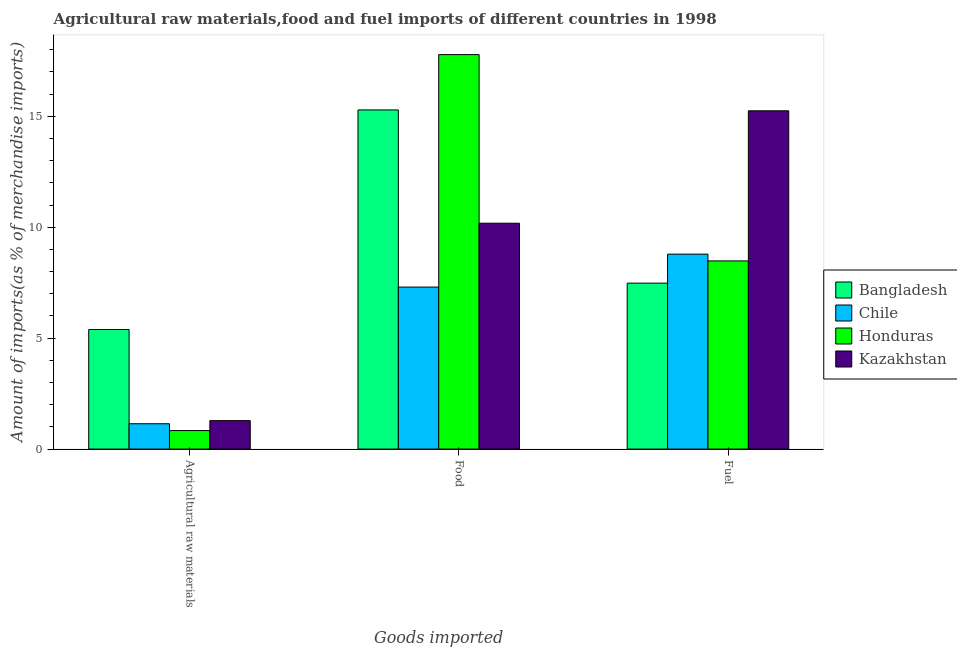How many groups of bars are there?
Your answer should be compact. 3. Are the number of bars per tick equal to the number of legend labels?
Ensure brevity in your answer.  Yes. What is the label of the 3rd group of bars from the left?
Your answer should be very brief. Fuel. What is the percentage of raw materials imports in Chile?
Your answer should be compact. 1.14. Across all countries, what is the maximum percentage of food imports?
Offer a very short reply. 17.78. Across all countries, what is the minimum percentage of food imports?
Make the answer very short. 7.3. In which country was the percentage of food imports minimum?
Offer a terse response. Chile. What is the total percentage of food imports in the graph?
Your answer should be compact. 50.55. What is the difference between the percentage of fuel imports in Honduras and that in Chile?
Give a very brief answer. -0.31. What is the difference between the percentage of fuel imports in Honduras and the percentage of raw materials imports in Kazakhstan?
Your answer should be compact. 7.2. What is the average percentage of food imports per country?
Your answer should be very brief. 12.64. What is the difference between the percentage of raw materials imports and percentage of fuel imports in Honduras?
Your response must be concise. -7.65. What is the ratio of the percentage of fuel imports in Bangladesh to that in Chile?
Your answer should be compact. 0.85. Is the percentage of fuel imports in Bangladesh less than that in Chile?
Offer a terse response. Yes. Is the difference between the percentage of fuel imports in Honduras and Chile greater than the difference between the percentage of food imports in Honduras and Chile?
Your response must be concise. No. What is the difference between the highest and the second highest percentage of food imports?
Provide a succinct answer. 2.49. What is the difference between the highest and the lowest percentage of fuel imports?
Provide a succinct answer. 7.77. Is the sum of the percentage of raw materials imports in Kazakhstan and Bangladesh greater than the maximum percentage of food imports across all countries?
Keep it short and to the point. No. What does the 2nd bar from the left in Agricultural raw materials represents?
Give a very brief answer. Chile. What does the 4th bar from the right in Agricultural raw materials represents?
Provide a short and direct response. Bangladesh. Is it the case that in every country, the sum of the percentage of raw materials imports and percentage of food imports is greater than the percentage of fuel imports?
Offer a terse response. No. Are all the bars in the graph horizontal?
Keep it short and to the point. No. How many countries are there in the graph?
Your answer should be compact. 4. Are the values on the major ticks of Y-axis written in scientific E-notation?
Offer a terse response. No. Does the graph contain any zero values?
Provide a succinct answer. No. Does the graph contain grids?
Offer a terse response. No. Where does the legend appear in the graph?
Your answer should be very brief. Center right. How many legend labels are there?
Offer a very short reply. 4. What is the title of the graph?
Your response must be concise. Agricultural raw materials,food and fuel imports of different countries in 1998. Does "Norway" appear as one of the legend labels in the graph?
Keep it short and to the point. No. What is the label or title of the X-axis?
Offer a terse response. Goods imported. What is the label or title of the Y-axis?
Your response must be concise. Amount of imports(as % of merchandise imports). What is the Amount of imports(as % of merchandise imports) of Bangladesh in Agricultural raw materials?
Make the answer very short. 5.39. What is the Amount of imports(as % of merchandise imports) in Chile in Agricultural raw materials?
Offer a terse response. 1.14. What is the Amount of imports(as % of merchandise imports) of Honduras in Agricultural raw materials?
Give a very brief answer. 0.83. What is the Amount of imports(as % of merchandise imports) in Kazakhstan in Agricultural raw materials?
Make the answer very short. 1.28. What is the Amount of imports(as % of merchandise imports) in Bangladesh in Food?
Your answer should be compact. 15.29. What is the Amount of imports(as % of merchandise imports) of Chile in Food?
Provide a succinct answer. 7.3. What is the Amount of imports(as % of merchandise imports) of Honduras in Food?
Your answer should be compact. 17.78. What is the Amount of imports(as % of merchandise imports) of Kazakhstan in Food?
Make the answer very short. 10.18. What is the Amount of imports(as % of merchandise imports) of Bangladesh in Fuel?
Provide a short and direct response. 7.48. What is the Amount of imports(as % of merchandise imports) in Chile in Fuel?
Your answer should be very brief. 8.79. What is the Amount of imports(as % of merchandise imports) of Honduras in Fuel?
Your response must be concise. 8.48. What is the Amount of imports(as % of merchandise imports) of Kazakhstan in Fuel?
Keep it short and to the point. 15.25. Across all Goods imported, what is the maximum Amount of imports(as % of merchandise imports) in Bangladesh?
Offer a terse response. 15.29. Across all Goods imported, what is the maximum Amount of imports(as % of merchandise imports) in Chile?
Your answer should be very brief. 8.79. Across all Goods imported, what is the maximum Amount of imports(as % of merchandise imports) of Honduras?
Offer a terse response. 17.78. Across all Goods imported, what is the maximum Amount of imports(as % of merchandise imports) of Kazakhstan?
Provide a short and direct response. 15.25. Across all Goods imported, what is the minimum Amount of imports(as % of merchandise imports) in Bangladesh?
Your response must be concise. 5.39. Across all Goods imported, what is the minimum Amount of imports(as % of merchandise imports) in Chile?
Make the answer very short. 1.14. Across all Goods imported, what is the minimum Amount of imports(as % of merchandise imports) of Honduras?
Your answer should be very brief. 0.83. Across all Goods imported, what is the minimum Amount of imports(as % of merchandise imports) in Kazakhstan?
Ensure brevity in your answer.  1.28. What is the total Amount of imports(as % of merchandise imports) in Bangladesh in the graph?
Your answer should be compact. 28.15. What is the total Amount of imports(as % of merchandise imports) in Chile in the graph?
Your response must be concise. 17.23. What is the total Amount of imports(as % of merchandise imports) in Honduras in the graph?
Offer a terse response. 27.09. What is the total Amount of imports(as % of merchandise imports) of Kazakhstan in the graph?
Offer a very short reply. 26.71. What is the difference between the Amount of imports(as % of merchandise imports) of Bangladesh in Agricultural raw materials and that in Food?
Provide a succinct answer. -9.9. What is the difference between the Amount of imports(as % of merchandise imports) of Chile in Agricultural raw materials and that in Food?
Give a very brief answer. -6.16. What is the difference between the Amount of imports(as % of merchandise imports) in Honduras in Agricultural raw materials and that in Food?
Ensure brevity in your answer.  -16.95. What is the difference between the Amount of imports(as % of merchandise imports) of Kazakhstan in Agricultural raw materials and that in Food?
Keep it short and to the point. -8.9. What is the difference between the Amount of imports(as % of merchandise imports) in Bangladesh in Agricultural raw materials and that in Fuel?
Keep it short and to the point. -2.09. What is the difference between the Amount of imports(as % of merchandise imports) in Chile in Agricultural raw materials and that in Fuel?
Keep it short and to the point. -7.64. What is the difference between the Amount of imports(as % of merchandise imports) of Honduras in Agricultural raw materials and that in Fuel?
Ensure brevity in your answer.  -7.65. What is the difference between the Amount of imports(as % of merchandise imports) in Kazakhstan in Agricultural raw materials and that in Fuel?
Your response must be concise. -13.96. What is the difference between the Amount of imports(as % of merchandise imports) of Bangladesh in Food and that in Fuel?
Offer a very short reply. 7.81. What is the difference between the Amount of imports(as % of merchandise imports) of Chile in Food and that in Fuel?
Your answer should be very brief. -1.48. What is the difference between the Amount of imports(as % of merchandise imports) in Honduras in Food and that in Fuel?
Your answer should be very brief. 9.3. What is the difference between the Amount of imports(as % of merchandise imports) of Kazakhstan in Food and that in Fuel?
Give a very brief answer. -5.07. What is the difference between the Amount of imports(as % of merchandise imports) of Bangladesh in Agricultural raw materials and the Amount of imports(as % of merchandise imports) of Chile in Food?
Ensure brevity in your answer.  -1.91. What is the difference between the Amount of imports(as % of merchandise imports) in Bangladesh in Agricultural raw materials and the Amount of imports(as % of merchandise imports) in Honduras in Food?
Ensure brevity in your answer.  -12.39. What is the difference between the Amount of imports(as % of merchandise imports) of Bangladesh in Agricultural raw materials and the Amount of imports(as % of merchandise imports) of Kazakhstan in Food?
Give a very brief answer. -4.79. What is the difference between the Amount of imports(as % of merchandise imports) in Chile in Agricultural raw materials and the Amount of imports(as % of merchandise imports) in Honduras in Food?
Your answer should be very brief. -16.64. What is the difference between the Amount of imports(as % of merchandise imports) of Chile in Agricultural raw materials and the Amount of imports(as % of merchandise imports) of Kazakhstan in Food?
Offer a terse response. -9.04. What is the difference between the Amount of imports(as % of merchandise imports) of Honduras in Agricultural raw materials and the Amount of imports(as % of merchandise imports) of Kazakhstan in Food?
Provide a short and direct response. -9.35. What is the difference between the Amount of imports(as % of merchandise imports) of Bangladesh in Agricultural raw materials and the Amount of imports(as % of merchandise imports) of Chile in Fuel?
Make the answer very short. -3.4. What is the difference between the Amount of imports(as % of merchandise imports) in Bangladesh in Agricultural raw materials and the Amount of imports(as % of merchandise imports) in Honduras in Fuel?
Your answer should be compact. -3.09. What is the difference between the Amount of imports(as % of merchandise imports) in Bangladesh in Agricultural raw materials and the Amount of imports(as % of merchandise imports) in Kazakhstan in Fuel?
Your answer should be very brief. -9.86. What is the difference between the Amount of imports(as % of merchandise imports) of Chile in Agricultural raw materials and the Amount of imports(as % of merchandise imports) of Honduras in Fuel?
Offer a very short reply. -7.34. What is the difference between the Amount of imports(as % of merchandise imports) of Chile in Agricultural raw materials and the Amount of imports(as % of merchandise imports) of Kazakhstan in Fuel?
Your answer should be compact. -14.11. What is the difference between the Amount of imports(as % of merchandise imports) in Honduras in Agricultural raw materials and the Amount of imports(as % of merchandise imports) in Kazakhstan in Fuel?
Offer a terse response. -14.41. What is the difference between the Amount of imports(as % of merchandise imports) in Bangladesh in Food and the Amount of imports(as % of merchandise imports) in Chile in Fuel?
Keep it short and to the point. 6.5. What is the difference between the Amount of imports(as % of merchandise imports) of Bangladesh in Food and the Amount of imports(as % of merchandise imports) of Honduras in Fuel?
Provide a succinct answer. 6.81. What is the difference between the Amount of imports(as % of merchandise imports) of Bangladesh in Food and the Amount of imports(as % of merchandise imports) of Kazakhstan in Fuel?
Give a very brief answer. 0.04. What is the difference between the Amount of imports(as % of merchandise imports) in Chile in Food and the Amount of imports(as % of merchandise imports) in Honduras in Fuel?
Your response must be concise. -1.18. What is the difference between the Amount of imports(as % of merchandise imports) in Chile in Food and the Amount of imports(as % of merchandise imports) in Kazakhstan in Fuel?
Provide a succinct answer. -7.94. What is the difference between the Amount of imports(as % of merchandise imports) of Honduras in Food and the Amount of imports(as % of merchandise imports) of Kazakhstan in Fuel?
Your answer should be very brief. 2.53. What is the average Amount of imports(as % of merchandise imports) in Bangladesh per Goods imported?
Make the answer very short. 9.38. What is the average Amount of imports(as % of merchandise imports) of Chile per Goods imported?
Your answer should be very brief. 5.74. What is the average Amount of imports(as % of merchandise imports) in Honduras per Goods imported?
Offer a very short reply. 9.03. What is the average Amount of imports(as % of merchandise imports) in Kazakhstan per Goods imported?
Keep it short and to the point. 8.9. What is the difference between the Amount of imports(as % of merchandise imports) in Bangladesh and Amount of imports(as % of merchandise imports) in Chile in Agricultural raw materials?
Keep it short and to the point. 4.25. What is the difference between the Amount of imports(as % of merchandise imports) of Bangladesh and Amount of imports(as % of merchandise imports) of Honduras in Agricultural raw materials?
Provide a short and direct response. 4.55. What is the difference between the Amount of imports(as % of merchandise imports) of Bangladesh and Amount of imports(as % of merchandise imports) of Kazakhstan in Agricultural raw materials?
Your answer should be compact. 4.11. What is the difference between the Amount of imports(as % of merchandise imports) in Chile and Amount of imports(as % of merchandise imports) in Honduras in Agricultural raw materials?
Your answer should be compact. 0.31. What is the difference between the Amount of imports(as % of merchandise imports) of Chile and Amount of imports(as % of merchandise imports) of Kazakhstan in Agricultural raw materials?
Your answer should be compact. -0.14. What is the difference between the Amount of imports(as % of merchandise imports) of Honduras and Amount of imports(as % of merchandise imports) of Kazakhstan in Agricultural raw materials?
Your response must be concise. -0.45. What is the difference between the Amount of imports(as % of merchandise imports) of Bangladesh and Amount of imports(as % of merchandise imports) of Chile in Food?
Make the answer very short. 7.98. What is the difference between the Amount of imports(as % of merchandise imports) of Bangladesh and Amount of imports(as % of merchandise imports) of Honduras in Food?
Your response must be concise. -2.49. What is the difference between the Amount of imports(as % of merchandise imports) of Bangladesh and Amount of imports(as % of merchandise imports) of Kazakhstan in Food?
Your response must be concise. 5.11. What is the difference between the Amount of imports(as % of merchandise imports) in Chile and Amount of imports(as % of merchandise imports) in Honduras in Food?
Make the answer very short. -10.48. What is the difference between the Amount of imports(as % of merchandise imports) of Chile and Amount of imports(as % of merchandise imports) of Kazakhstan in Food?
Your answer should be very brief. -2.88. What is the difference between the Amount of imports(as % of merchandise imports) in Honduras and Amount of imports(as % of merchandise imports) in Kazakhstan in Food?
Offer a very short reply. 7.6. What is the difference between the Amount of imports(as % of merchandise imports) in Bangladesh and Amount of imports(as % of merchandise imports) in Chile in Fuel?
Offer a terse response. -1.31. What is the difference between the Amount of imports(as % of merchandise imports) of Bangladesh and Amount of imports(as % of merchandise imports) of Honduras in Fuel?
Keep it short and to the point. -1. What is the difference between the Amount of imports(as % of merchandise imports) of Bangladesh and Amount of imports(as % of merchandise imports) of Kazakhstan in Fuel?
Your answer should be very brief. -7.77. What is the difference between the Amount of imports(as % of merchandise imports) of Chile and Amount of imports(as % of merchandise imports) of Honduras in Fuel?
Offer a terse response. 0.3. What is the difference between the Amount of imports(as % of merchandise imports) in Chile and Amount of imports(as % of merchandise imports) in Kazakhstan in Fuel?
Make the answer very short. -6.46. What is the difference between the Amount of imports(as % of merchandise imports) of Honduras and Amount of imports(as % of merchandise imports) of Kazakhstan in Fuel?
Your answer should be very brief. -6.77. What is the ratio of the Amount of imports(as % of merchandise imports) in Bangladesh in Agricultural raw materials to that in Food?
Make the answer very short. 0.35. What is the ratio of the Amount of imports(as % of merchandise imports) of Chile in Agricultural raw materials to that in Food?
Make the answer very short. 0.16. What is the ratio of the Amount of imports(as % of merchandise imports) of Honduras in Agricultural raw materials to that in Food?
Give a very brief answer. 0.05. What is the ratio of the Amount of imports(as % of merchandise imports) of Kazakhstan in Agricultural raw materials to that in Food?
Give a very brief answer. 0.13. What is the ratio of the Amount of imports(as % of merchandise imports) in Bangladesh in Agricultural raw materials to that in Fuel?
Your response must be concise. 0.72. What is the ratio of the Amount of imports(as % of merchandise imports) of Chile in Agricultural raw materials to that in Fuel?
Give a very brief answer. 0.13. What is the ratio of the Amount of imports(as % of merchandise imports) of Honduras in Agricultural raw materials to that in Fuel?
Provide a short and direct response. 0.1. What is the ratio of the Amount of imports(as % of merchandise imports) of Kazakhstan in Agricultural raw materials to that in Fuel?
Your answer should be compact. 0.08. What is the ratio of the Amount of imports(as % of merchandise imports) in Bangladesh in Food to that in Fuel?
Provide a short and direct response. 2.04. What is the ratio of the Amount of imports(as % of merchandise imports) in Chile in Food to that in Fuel?
Provide a short and direct response. 0.83. What is the ratio of the Amount of imports(as % of merchandise imports) of Honduras in Food to that in Fuel?
Offer a terse response. 2.1. What is the ratio of the Amount of imports(as % of merchandise imports) of Kazakhstan in Food to that in Fuel?
Make the answer very short. 0.67. What is the difference between the highest and the second highest Amount of imports(as % of merchandise imports) of Bangladesh?
Keep it short and to the point. 7.81. What is the difference between the highest and the second highest Amount of imports(as % of merchandise imports) of Chile?
Offer a terse response. 1.48. What is the difference between the highest and the second highest Amount of imports(as % of merchandise imports) of Honduras?
Your answer should be compact. 9.3. What is the difference between the highest and the second highest Amount of imports(as % of merchandise imports) in Kazakhstan?
Provide a succinct answer. 5.07. What is the difference between the highest and the lowest Amount of imports(as % of merchandise imports) in Bangladesh?
Keep it short and to the point. 9.9. What is the difference between the highest and the lowest Amount of imports(as % of merchandise imports) in Chile?
Offer a terse response. 7.64. What is the difference between the highest and the lowest Amount of imports(as % of merchandise imports) in Honduras?
Your answer should be compact. 16.95. What is the difference between the highest and the lowest Amount of imports(as % of merchandise imports) in Kazakhstan?
Your response must be concise. 13.96. 